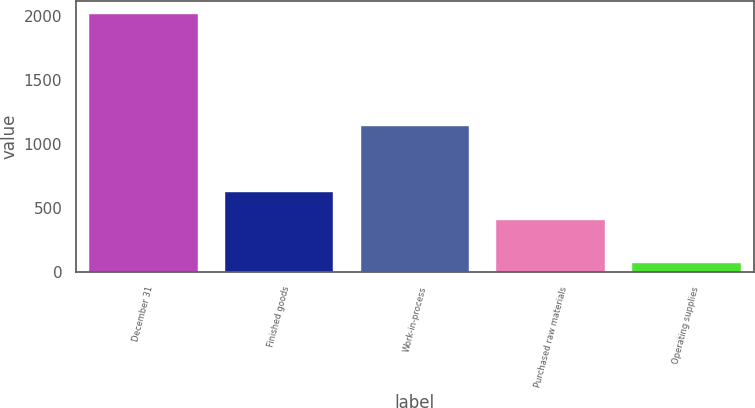Convert chart. <chart><loc_0><loc_0><loc_500><loc_500><bar_chart><fcel>December 31<fcel>Finished goods<fcel>Work-in-process<fcel>Purchased raw materials<fcel>Operating supplies<nl><fcel>2016<fcel>625<fcel>1144<fcel>408<fcel>76<nl></chart> 